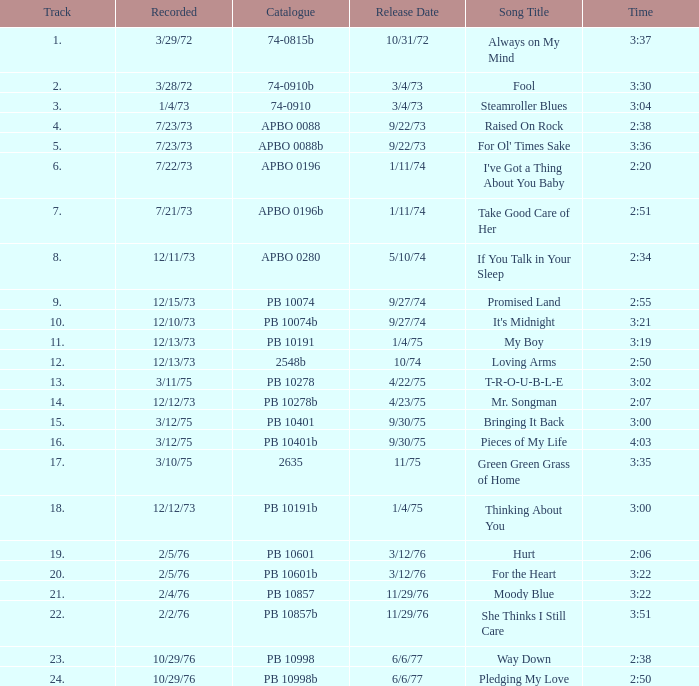What is the total number of tracks for raised on rock? 4.0. 